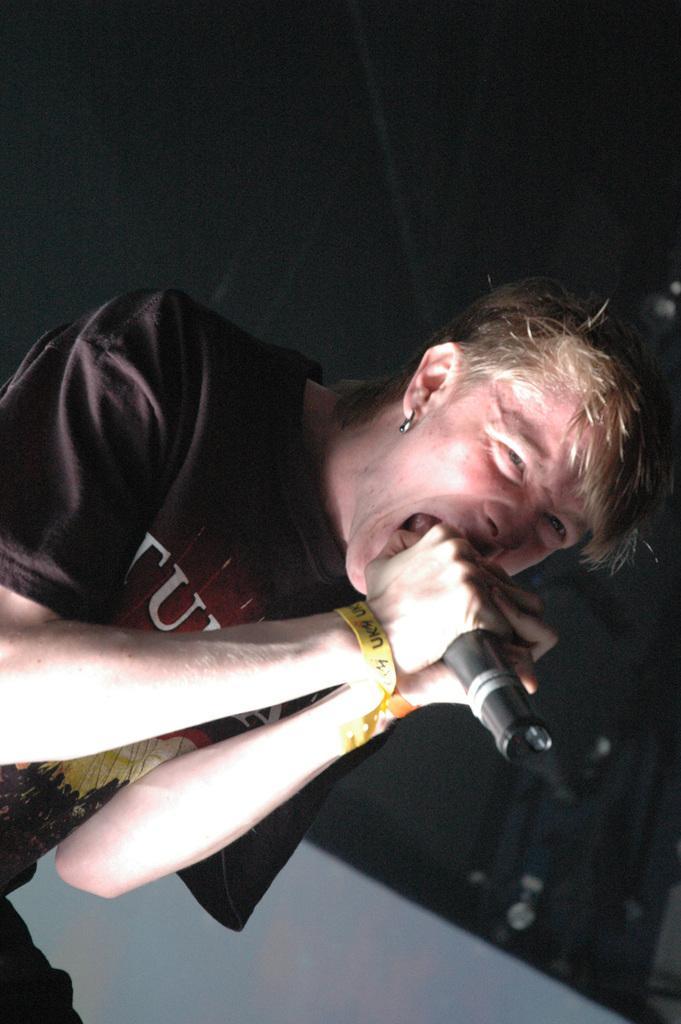Can you describe this image briefly? In this image there is a man holding a mic and singing. In the background there is black colour sheet and white colour object. 